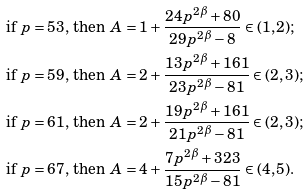<formula> <loc_0><loc_0><loc_500><loc_500>& \text {if $p=53$, then $A=1+\frac{24p^{2\beta}+80}{29 p^{2\beta}-8} \in (1,2)$;} \\ & \text {if $p=59$, then $A=2+\frac{ 13p^{2\beta}+161 }{ 23 p^{2\beta}-81 } \in (2,3)$;} \\ & \text {if $p=61$, then $A=2+\frac{ 19p^{2\beta}+161 }{ 21p^{2\beta}-81 } \in (2,3)$;} \\ & \text {if $p=67$, then $A=4+\frac{7p^{2\beta}+323} { 15p^{2\beta}-81} \in (4,5)$.}</formula> 